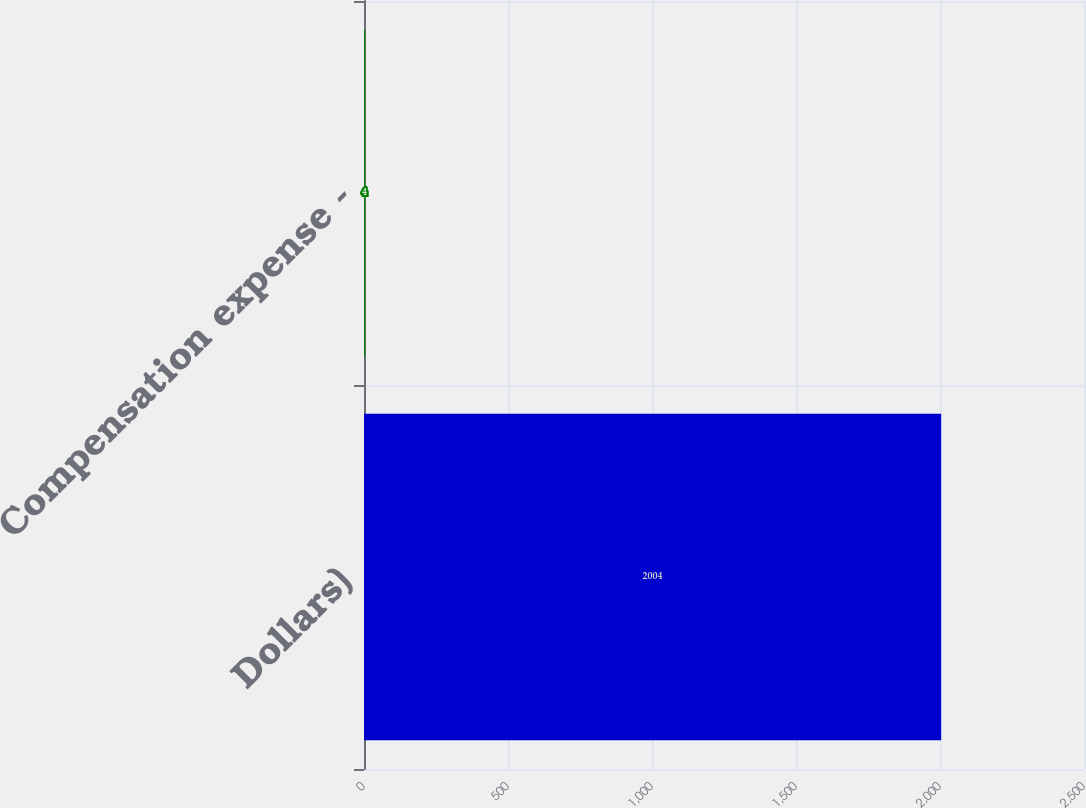Convert chart. <chart><loc_0><loc_0><loc_500><loc_500><bar_chart><fcel>Dollars)<fcel>Compensation expense -<nl><fcel>2004<fcel>4<nl></chart> 